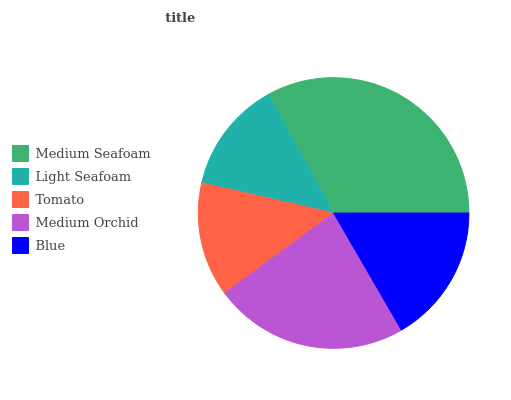Is Light Seafoam the minimum?
Answer yes or no. Yes. Is Medium Seafoam the maximum?
Answer yes or no. Yes. Is Tomato the minimum?
Answer yes or no. No. Is Tomato the maximum?
Answer yes or no. No. Is Tomato greater than Light Seafoam?
Answer yes or no. Yes. Is Light Seafoam less than Tomato?
Answer yes or no. Yes. Is Light Seafoam greater than Tomato?
Answer yes or no. No. Is Tomato less than Light Seafoam?
Answer yes or no. No. Is Blue the high median?
Answer yes or no. Yes. Is Blue the low median?
Answer yes or no. Yes. Is Medium Orchid the high median?
Answer yes or no. No. Is Tomato the low median?
Answer yes or no. No. 